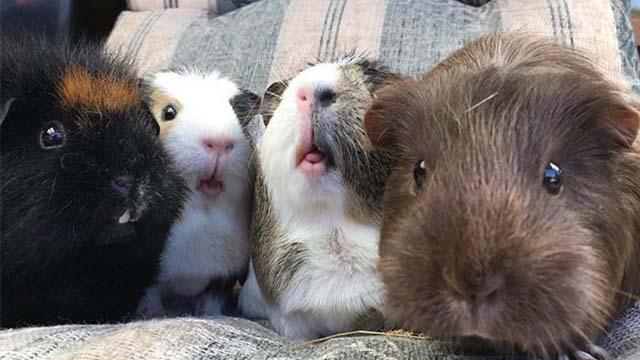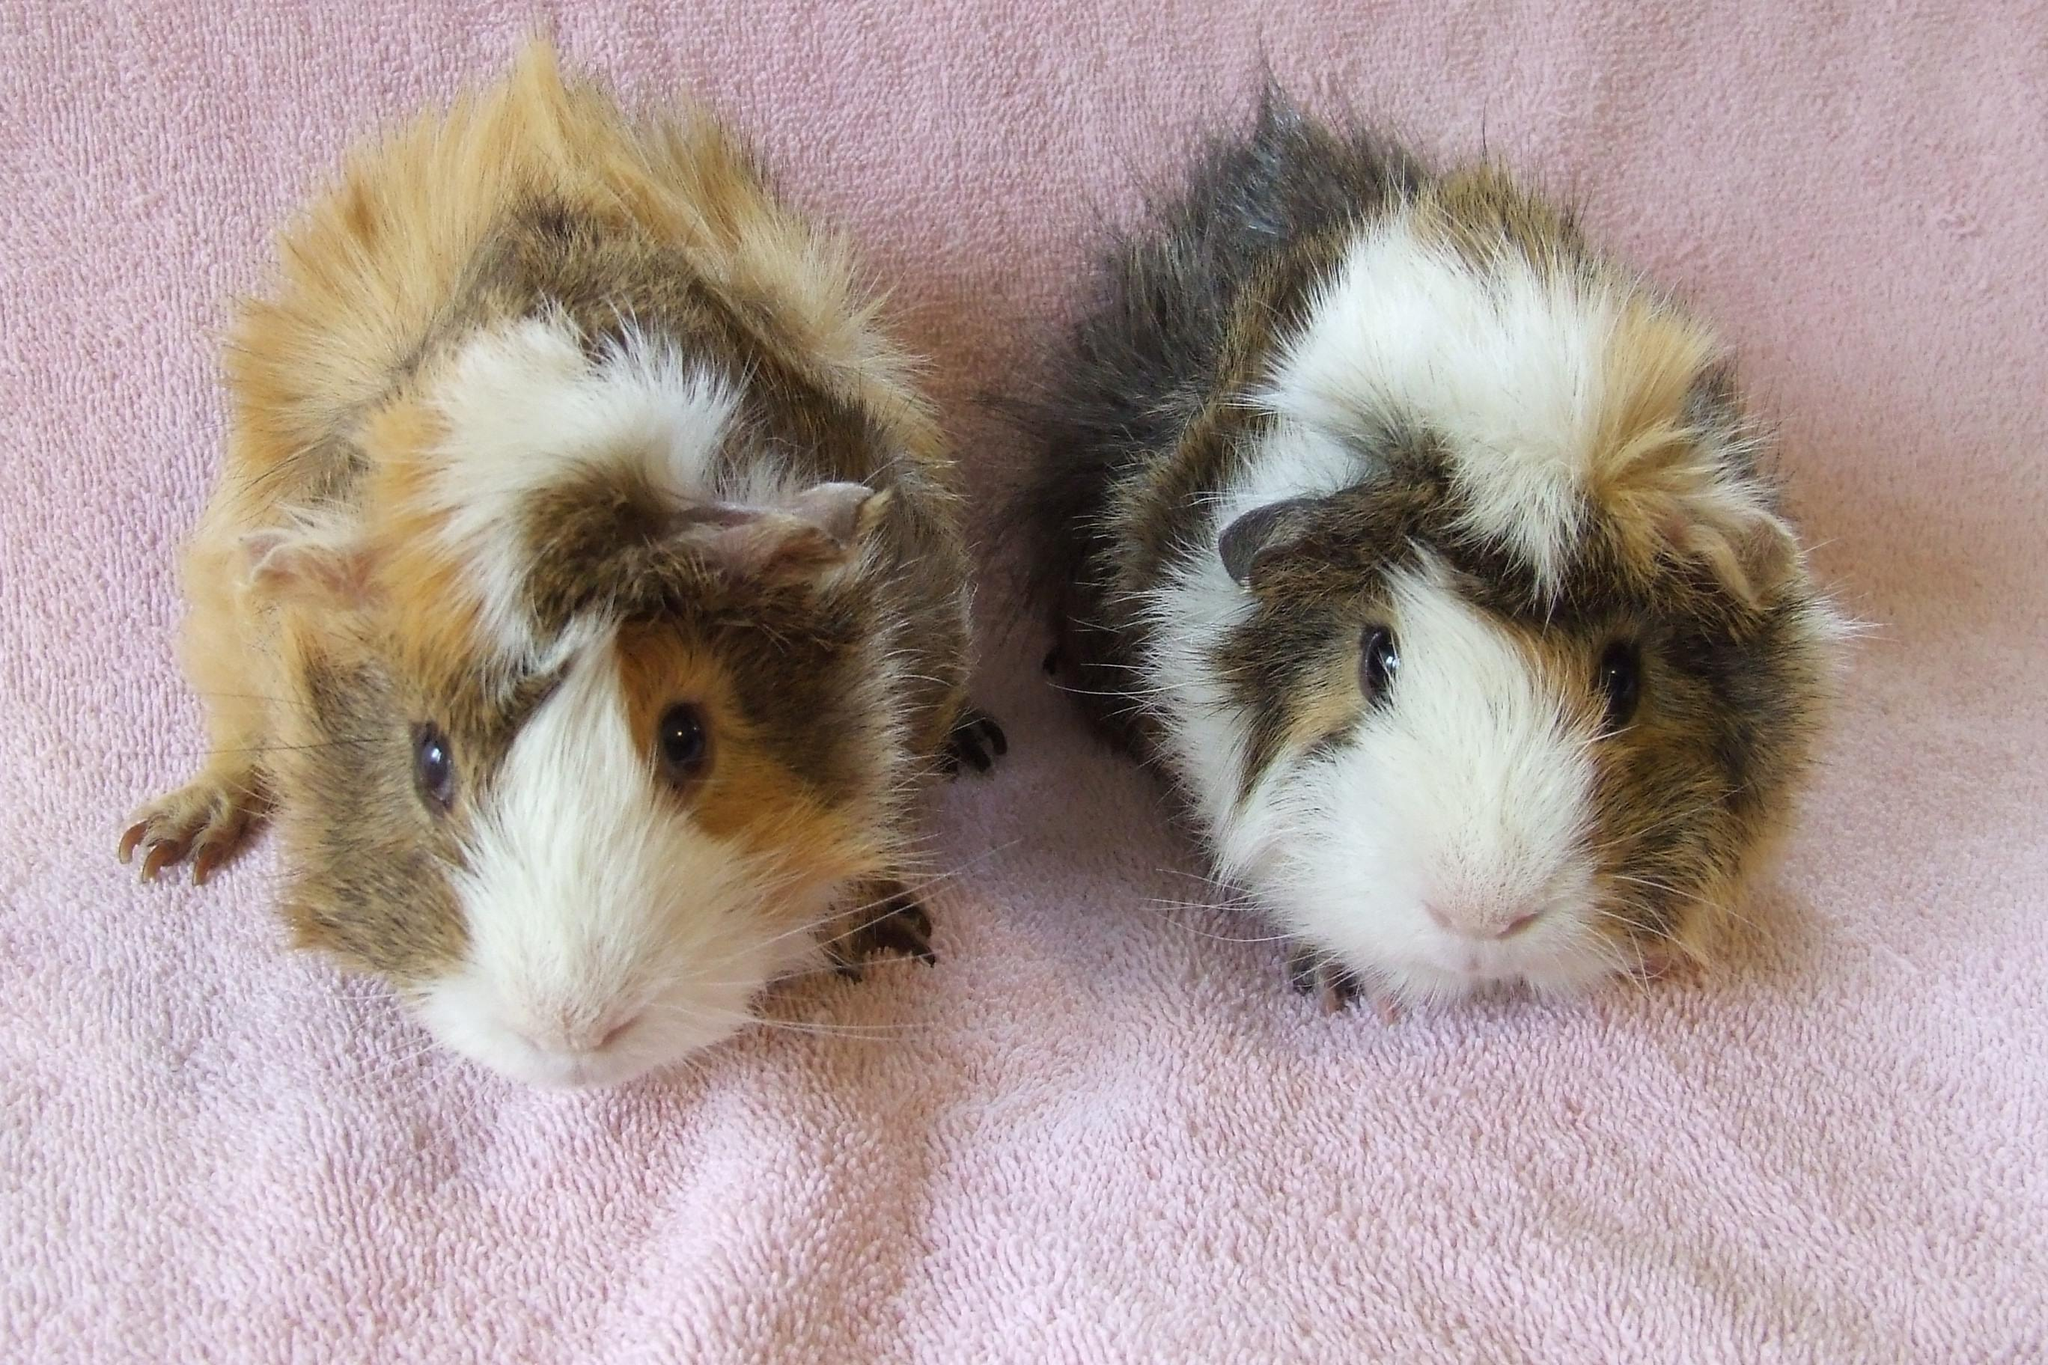The first image is the image on the left, the second image is the image on the right. Given the left and right images, does the statement "There are three hamsters in total." hold true? Answer yes or no. No. The first image is the image on the left, the second image is the image on the right. Considering the images on both sides, is "In total, three guinea pigs are shown, and the right image contains more animals than the left image." valid? Answer yes or no. No. 